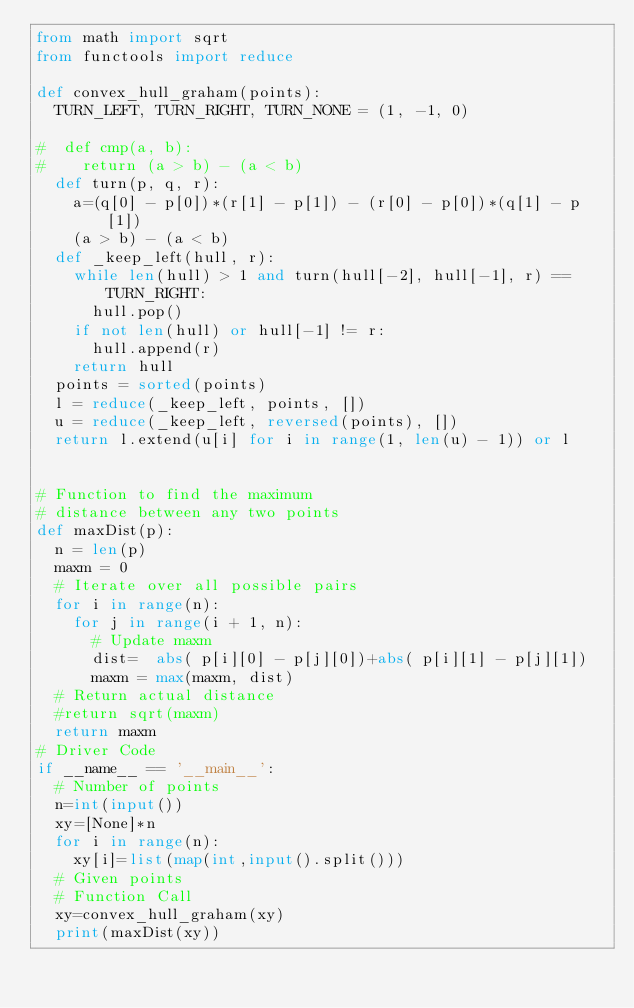Convert code to text. <code><loc_0><loc_0><loc_500><loc_500><_Python_>from math import sqrt
from functools import reduce

def convex_hull_graham(points):
  TURN_LEFT, TURN_RIGHT, TURN_NONE = (1, -1, 0)

#  def cmp(a, b):
#    return (a > b) - (a < b)
  def turn(p, q, r):
    a=(q[0] - p[0])*(r[1] - p[1]) - (r[0] - p[0])*(q[1] - p[1])
    (a > b) - (a < b)
  def _keep_left(hull, r):
    while len(hull) > 1 and turn(hull[-2], hull[-1], r) == TURN_RIGHT:
      hull.pop()
    if not len(hull) or hull[-1] != r:
      hull.append(r)
    return hull
  points = sorted(points)
  l = reduce(_keep_left, points, [])
  u = reduce(_keep_left, reversed(points), [])
  return l.extend(u[i] for i in range(1, len(u) - 1)) or l


# Function to find the maximum 
# distance between any two points 
def maxDist(p): 
  n = len(p) 
  maxm = 0
  # Iterate over all possible pairs 
  for i in range(n): 
    for j in range(i + 1, n): 
      # Update maxm
      dist=  abs( p[i][0] - p[j][0])+abs( p[i][1] - p[j][1]) 
      maxm = max(maxm, dist) 
  # Return actual distance 
  #return sqrt(maxm) 
  return maxm
# Driver Code 
if __name__ == '__main__': 
  # Number of points 
  n=int(input())
  xy=[None]*n
  for i in range(n):
    xy[i]=list(map(int,input().split()))
  # Given points 
  # Function Call 
  xy=convex_hull_graham(xy)
  print(maxDist(xy)) </code> 